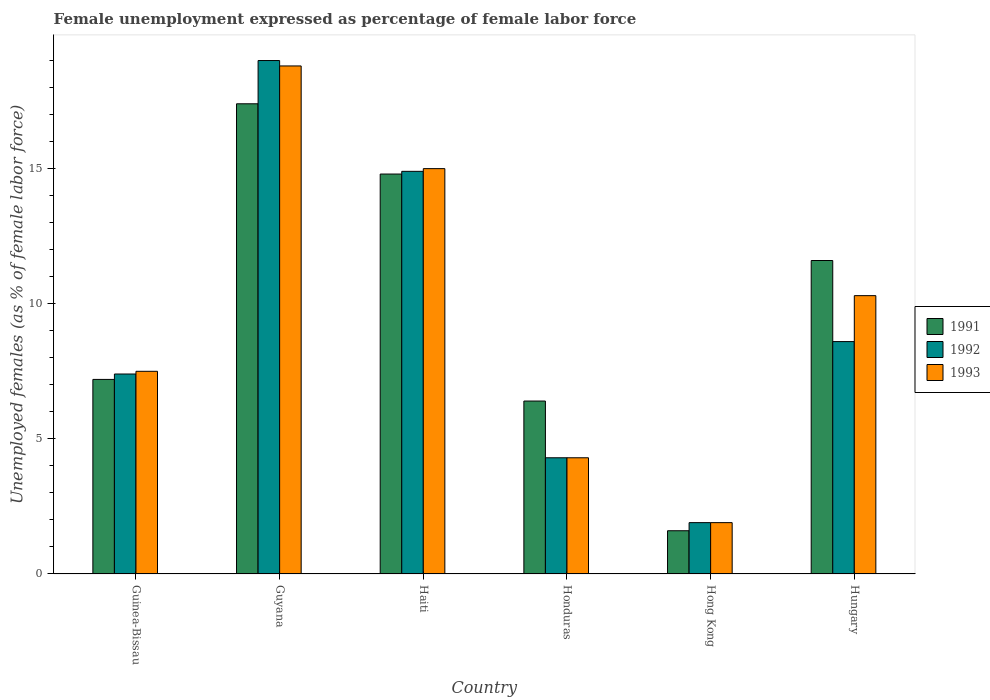How many bars are there on the 3rd tick from the right?
Your answer should be compact. 3. What is the label of the 4th group of bars from the left?
Give a very brief answer. Honduras. In how many cases, is the number of bars for a given country not equal to the number of legend labels?
Your answer should be compact. 0. What is the unemployment in females in in 1991 in Haiti?
Your answer should be compact. 14.8. Across all countries, what is the maximum unemployment in females in in 1993?
Ensure brevity in your answer.  18.8. Across all countries, what is the minimum unemployment in females in in 1993?
Ensure brevity in your answer.  1.9. In which country was the unemployment in females in in 1993 maximum?
Your response must be concise. Guyana. In which country was the unemployment in females in in 1993 minimum?
Provide a short and direct response. Hong Kong. What is the total unemployment in females in in 1992 in the graph?
Your answer should be very brief. 56.1. What is the difference between the unemployment in females in in 1993 in Honduras and that in Hong Kong?
Your answer should be compact. 2.4. What is the difference between the unemployment in females in in 1991 in Guyana and the unemployment in females in in 1993 in Hong Kong?
Your answer should be very brief. 15.5. What is the average unemployment in females in in 1993 per country?
Keep it short and to the point. 9.63. What is the difference between the unemployment in females in of/in 1993 and unemployment in females in of/in 1991 in Haiti?
Your answer should be compact. 0.2. What is the ratio of the unemployment in females in in 1993 in Haiti to that in Hong Kong?
Give a very brief answer. 7.89. Is the unemployment in females in in 1992 in Honduras less than that in Hong Kong?
Keep it short and to the point. No. What is the difference between the highest and the second highest unemployment in females in in 1992?
Give a very brief answer. -10.4. What is the difference between the highest and the lowest unemployment in females in in 1993?
Offer a very short reply. 16.9. What does the 2nd bar from the right in Haiti represents?
Give a very brief answer. 1992. Is it the case that in every country, the sum of the unemployment in females in in 1992 and unemployment in females in in 1993 is greater than the unemployment in females in in 1991?
Offer a terse response. Yes. Are all the bars in the graph horizontal?
Your answer should be very brief. No. Where does the legend appear in the graph?
Keep it short and to the point. Center right. How are the legend labels stacked?
Your answer should be very brief. Vertical. What is the title of the graph?
Make the answer very short. Female unemployment expressed as percentage of female labor force. What is the label or title of the Y-axis?
Keep it short and to the point. Unemployed females (as % of female labor force). What is the Unemployed females (as % of female labor force) in 1991 in Guinea-Bissau?
Your response must be concise. 7.2. What is the Unemployed females (as % of female labor force) of 1992 in Guinea-Bissau?
Give a very brief answer. 7.4. What is the Unemployed females (as % of female labor force) in 1993 in Guinea-Bissau?
Your response must be concise. 7.5. What is the Unemployed females (as % of female labor force) in 1991 in Guyana?
Offer a very short reply. 17.4. What is the Unemployed females (as % of female labor force) in 1993 in Guyana?
Provide a succinct answer. 18.8. What is the Unemployed females (as % of female labor force) of 1991 in Haiti?
Keep it short and to the point. 14.8. What is the Unemployed females (as % of female labor force) in 1992 in Haiti?
Provide a succinct answer. 14.9. What is the Unemployed females (as % of female labor force) of 1991 in Honduras?
Your answer should be compact. 6.4. What is the Unemployed females (as % of female labor force) of 1992 in Honduras?
Keep it short and to the point. 4.3. What is the Unemployed females (as % of female labor force) of 1993 in Honduras?
Give a very brief answer. 4.3. What is the Unemployed females (as % of female labor force) in 1991 in Hong Kong?
Provide a short and direct response. 1.6. What is the Unemployed females (as % of female labor force) in 1992 in Hong Kong?
Provide a succinct answer. 1.9. What is the Unemployed females (as % of female labor force) in 1993 in Hong Kong?
Offer a very short reply. 1.9. What is the Unemployed females (as % of female labor force) of 1991 in Hungary?
Your response must be concise. 11.6. What is the Unemployed females (as % of female labor force) in 1992 in Hungary?
Make the answer very short. 8.6. What is the Unemployed females (as % of female labor force) in 1993 in Hungary?
Your answer should be very brief. 10.3. Across all countries, what is the maximum Unemployed females (as % of female labor force) of 1991?
Ensure brevity in your answer.  17.4. Across all countries, what is the maximum Unemployed females (as % of female labor force) of 1992?
Ensure brevity in your answer.  19. Across all countries, what is the maximum Unemployed females (as % of female labor force) of 1993?
Your response must be concise. 18.8. Across all countries, what is the minimum Unemployed females (as % of female labor force) in 1991?
Your response must be concise. 1.6. Across all countries, what is the minimum Unemployed females (as % of female labor force) of 1992?
Ensure brevity in your answer.  1.9. Across all countries, what is the minimum Unemployed females (as % of female labor force) in 1993?
Your response must be concise. 1.9. What is the total Unemployed females (as % of female labor force) in 1992 in the graph?
Your answer should be compact. 56.1. What is the total Unemployed females (as % of female labor force) of 1993 in the graph?
Offer a terse response. 57.8. What is the difference between the Unemployed females (as % of female labor force) in 1992 in Guinea-Bissau and that in Guyana?
Provide a succinct answer. -11.6. What is the difference between the Unemployed females (as % of female labor force) in 1993 in Guinea-Bissau and that in Guyana?
Ensure brevity in your answer.  -11.3. What is the difference between the Unemployed females (as % of female labor force) of 1992 in Guinea-Bissau and that in Haiti?
Make the answer very short. -7.5. What is the difference between the Unemployed females (as % of female labor force) in 1993 in Guinea-Bissau and that in Haiti?
Keep it short and to the point. -7.5. What is the difference between the Unemployed females (as % of female labor force) of 1992 in Guinea-Bissau and that in Honduras?
Your answer should be compact. 3.1. What is the difference between the Unemployed females (as % of female labor force) in 1991 in Guinea-Bissau and that in Hong Kong?
Your answer should be compact. 5.6. What is the difference between the Unemployed females (as % of female labor force) of 1992 in Guinea-Bissau and that in Hong Kong?
Ensure brevity in your answer.  5.5. What is the difference between the Unemployed females (as % of female labor force) in 1993 in Guinea-Bissau and that in Hong Kong?
Keep it short and to the point. 5.6. What is the difference between the Unemployed females (as % of female labor force) of 1991 in Guinea-Bissau and that in Hungary?
Ensure brevity in your answer.  -4.4. What is the difference between the Unemployed females (as % of female labor force) of 1992 in Guinea-Bissau and that in Hungary?
Your answer should be compact. -1.2. What is the difference between the Unemployed females (as % of female labor force) in 1993 in Guinea-Bissau and that in Hungary?
Make the answer very short. -2.8. What is the difference between the Unemployed females (as % of female labor force) of 1992 in Guyana and that in Haiti?
Give a very brief answer. 4.1. What is the difference between the Unemployed females (as % of female labor force) of 1991 in Guyana and that in Honduras?
Your answer should be compact. 11. What is the difference between the Unemployed females (as % of female labor force) in 1992 in Guyana and that in Honduras?
Ensure brevity in your answer.  14.7. What is the difference between the Unemployed females (as % of female labor force) in 1993 in Guyana and that in Honduras?
Your answer should be compact. 14.5. What is the difference between the Unemployed females (as % of female labor force) in 1991 in Guyana and that in Hong Kong?
Your answer should be very brief. 15.8. What is the difference between the Unemployed females (as % of female labor force) in 1991 in Guyana and that in Hungary?
Your answer should be compact. 5.8. What is the difference between the Unemployed females (as % of female labor force) in 1991 in Haiti and that in Hong Kong?
Your answer should be compact. 13.2. What is the difference between the Unemployed females (as % of female labor force) in 1992 in Haiti and that in Hong Kong?
Your answer should be very brief. 13. What is the difference between the Unemployed females (as % of female labor force) in 1991 in Haiti and that in Hungary?
Ensure brevity in your answer.  3.2. What is the difference between the Unemployed females (as % of female labor force) of 1991 in Honduras and that in Hungary?
Make the answer very short. -5.2. What is the difference between the Unemployed females (as % of female labor force) in 1992 in Honduras and that in Hungary?
Your answer should be compact. -4.3. What is the difference between the Unemployed females (as % of female labor force) of 1993 in Honduras and that in Hungary?
Keep it short and to the point. -6. What is the difference between the Unemployed females (as % of female labor force) of 1991 in Hong Kong and that in Hungary?
Give a very brief answer. -10. What is the difference between the Unemployed females (as % of female labor force) of 1992 in Hong Kong and that in Hungary?
Your answer should be very brief. -6.7. What is the difference between the Unemployed females (as % of female labor force) in 1993 in Hong Kong and that in Hungary?
Your response must be concise. -8.4. What is the difference between the Unemployed females (as % of female labor force) in 1991 in Guinea-Bissau and the Unemployed females (as % of female labor force) in 1993 in Haiti?
Your answer should be very brief. -7.8. What is the difference between the Unemployed females (as % of female labor force) of 1992 in Guinea-Bissau and the Unemployed females (as % of female labor force) of 1993 in Haiti?
Your response must be concise. -7.6. What is the difference between the Unemployed females (as % of female labor force) of 1991 in Guinea-Bissau and the Unemployed females (as % of female labor force) of 1992 in Honduras?
Ensure brevity in your answer.  2.9. What is the difference between the Unemployed females (as % of female labor force) in 1991 in Guinea-Bissau and the Unemployed females (as % of female labor force) in 1993 in Honduras?
Offer a very short reply. 2.9. What is the difference between the Unemployed females (as % of female labor force) in 1992 in Guinea-Bissau and the Unemployed females (as % of female labor force) in 1993 in Honduras?
Offer a very short reply. 3.1. What is the difference between the Unemployed females (as % of female labor force) of 1991 in Guinea-Bissau and the Unemployed females (as % of female labor force) of 1992 in Hong Kong?
Ensure brevity in your answer.  5.3. What is the difference between the Unemployed females (as % of female labor force) of 1992 in Guinea-Bissau and the Unemployed females (as % of female labor force) of 1993 in Hungary?
Provide a succinct answer. -2.9. What is the difference between the Unemployed females (as % of female labor force) in 1991 in Guyana and the Unemployed females (as % of female labor force) in 1992 in Haiti?
Provide a succinct answer. 2.5. What is the difference between the Unemployed females (as % of female labor force) of 1991 in Guyana and the Unemployed females (as % of female labor force) of 1993 in Haiti?
Your response must be concise. 2.4. What is the difference between the Unemployed females (as % of female labor force) of 1992 in Guyana and the Unemployed females (as % of female labor force) of 1993 in Haiti?
Your answer should be compact. 4. What is the difference between the Unemployed females (as % of female labor force) in 1991 in Guyana and the Unemployed females (as % of female labor force) in 1992 in Honduras?
Provide a succinct answer. 13.1. What is the difference between the Unemployed females (as % of female labor force) in 1991 in Guyana and the Unemployed females (as % of female labor force) in 1992 in Hong Kong?
Ensure brevity in your answer.  15.5. What is the difference between the Unemployed females (as % of female labor force) in 1992 in Guyana and the Unemployed females (as % of female labor force) in 1993 in Hong Kong?
Keep it short and to the point. 17.1. What is the difference between the Unemployed females (as % of female labor force) in 1992 in Guyana and the Unemployed females (as % of female labor force) in 1993 in Hungary?
Your response must be concise. 8.7. What is the difference between the Unemployed females (as % of female labor force) of 1991 in Haiti and the Unemployed females (as % of female labor force) of 1992 in Honduras?
Your response must be concise. 10.5. What is the difference between the Unemployed females (as % of female labor force) in 1991 in Haiti and the Unemployed females (as % of female labor force) in 1993 in Honduras?
Offer a terse response. 10.5. What is the difference between the Unemployed females (as % of female labor force) of 1991 in Haiti and the Unemployed females (as % of female labor force) of 1993 in Hong Kong?
Give a very brief answer. 12.9. What is the difference between the Unemployed females (as % of female labor force) of 1992 in Haiti and the Unemployed females (as % of female labor force) of 1993 in Hong Kong?
Keep it short and to the point. 13. What is the difference between the Unemployed females (as % of female labor force) of 1991 in Haiti and the Unemployed females (as % of female labor force) of 1992 in Hungary?
Give a very brief answer. 6.2. What is the difference between the Unemployed females (as % of female labor force) of 1991 in Haiti and the Unemployed females (as % of female labor force) of 1993 in Hungary?
Provide a succinct answer. 4.5. What is the difference between the Unemployed females (as % of female labor force) in 1991 in Honduras and the Unemployed females (as % of female labor force) in 1992 in Hungary?
Keep it short and to the point. -2.2. What is the difference between the Unemployed females (as % of female labor force) in 1992 in Honduras and the Unemployed females (as % of female labor force) in 1993 in Hungary?
Make the answer very short. -6. What is the difference between the Unemployed females (as % of female labor force) of 1991 in Hong Kong and the Unemployed females (as % of female labor force) of 1993 in Hungary?
Offer a very short reply. -8.7. What is the average Unemployed females (as % of female labor force) of 1991 per country?
Offer a terse response. 9.83. What is the average Unemployed females (as % of female labor force) of 1992 per country?
Your response must be concise. 9.35. What is the average Unemployed females (as % of female labor force) in 1993 per country?
Your response must be concise. 9.63. What is the difference between the Unemployed females (as % of female labor force) of 1991 and Unemployed females (as % of female labor force) of 1993 in Guinea-Bissau?
Provide a succinct answer. -0.3. What is the difference between the Unemployed females (as % of female labor force) of 1991 and Unemployed females (as % of female labor force) of 1992 in Guyana?
Offer a very short reply. -1.6. What is the difference between the Unemployed females (as % of female labor force) in 1991 and Unemployed females (as % of female labor force) in 1993 in Guyana?
Keep it short and to the point. -1.4. What is the difference between the Unemployed females (as % of female labor force) of 1991 and Unemployed females (as % of female labor force) of 1992 in Haiti?
Your answer should be very brief. -0.1. What is the difference between the Unemployed females (as % of female labor force) of 1992 and Unemployed females (as % of female labor force) of 1993 in Haiti?
Offer a very short reply. -0.1. What is the difference between the Unemployed females (as % of female labor force) in 1991 and Unemployed females (as % of female labor force) in 1992 in Honduras?
Make the answer very short. 2.1. What is the difference between the Unemployed females (as % of female labor force) in 1991 and Unemployed females (as % of female labor force) in 1993 in Honduras?
Make the answer very short. 2.1. What is the difference between the Unemployed females (as % of female labor force) in 1992 and Unemployed females (as % of female labor force) in 1993 in Honduras?
Ensure brevity in your answer.  0. What is the difference between the Unemployed females (as % of female labor force) in 1991 and Unemployed females (as % of female labor force) in 1992 in Hungary?
Provide a short and direct response. 3. What is the difference between the Unemployed females (as % of female labor force) in 1991 and Unemployed females (as % of female labor force) in 1993 in Hungary?
Keep it short and to the point. 1.3. What is the difference between the Unemployed females (as % of female labor force) of 1992 and Unemployed females (as % of female labor force) of 1993 in Hungary?
Your answer should be very brief. -1.7. What is the ratio of the Unemployed females (as % of female labor force) of 1991 in Guinea-Bissau to that in Guyana?
Provide a succinct answer. 0.41. What is the ratio of the Unemployed females (as % of female labor force) in 1992 in Guinea-Bissau to that in Guyana?
Your answer should be compact. 0.39. What is the ratio of the Unemployed females (as % of female labor force) in 1993 in Guinea-Bissau to that in Guyana?
Provide a short and direct response. 0.4. What is the ratio of the Unemployed females (as % of female labor force) in 1991 in Guinea-Bissau to that in Haiti?
Make the answer very short. 0.49. What is the ratio of the Unemployed females (as % of female labor force) in 1992 in Guinea-Bissau to that in Haiti?
Offer a terse response. 0.5. What is the ratio of the Unemployed females (as % of female labor force) in 1992 in Guinea-Bissau to that in Honduras?
Your answer should be compact. 1.72. What is the ratio of the Unemployed females (as % of female labor force) of 1993 in Guinea-Bissau to that in Honduras?
Offer a terse response. 1.74. What is the ratio of the Unemployed females (as % of female labor force) in 1992 in Guinea-Bissau to that in Hong Kong?
Ensure brevity in your answer.  3.89. What is the ratio of the Unemployed females (as % of female labor force) of 1993 in Guinea-Bissau to that in Hong Kong?
Your response must be concise. 3.95. What is the ratio of the Unemployed females (as % of female labor force) in 1991 in Guinea-Bissau to that in Hungary?
Provide a short and direct response. 0.62. What is the ratio of the Unemployed females (as % of female labor force) in 1992 in Guinea-Bissau to that in Hungary?
Make the answer very short. 0.86. What is the ratio of the Unemployed females (as % of female labor force) in 1993 in Guinea-Bissau to that in Hungary?
Provide a short and direct response. 0.73. What is the ratio of the Unemployed females (as % of female labor force) of 1991 in Guyana to that in Haiti?
Your answer should be very brief. 1.18. What is the ratio of the Unemployed females (as % of female labor force) in 1992 in Guyana to that in Haiti?
Make the answer very short. 1.28. What is the ratio of the Unemployed females (as % of female labor force) in 1993 in Guyana to that in Haiti?
Offer a very short reply. 1.25. What is the ratio of the Unemployed females (as % of female labor force) of 1991 in Guyana to that in Honduras?
Offer a very short reply. 2.72. What is the ratio of the Unemployed females (as % of female labor force) of 1992 in Guyana to that in Honduras?
Your answer should be compact. 4.42. What is the ratio of the Unemployed females (as % of female labor force) of 1993 in Guyana to that in Honduras?
Make the answer very short. 4.37. What is the ratio of the Unemployed females (as % of female labor force) of 1991 in Guyana to that in Hong Kong?
Give a very brief answer. 10.88. What is the ratio of the Unemployed females (as % of female labor force) in 1993 in Guyana to that in Hong Kong?
Provide a succinct answer. 9.89. What is the ratio of the Unemployed females (as % of female labor force) of 1992 in Guyana to that in Hungary?
Ensure brevity in your answer.  2.21. What is the ratio of the Unemployed females (as % of female labor force) in 1993 in Guyana to that in Hungary?
Give a very brief answer. 1.83. What is the ratio of the Unemployed females (as % of female labor force) of 1991 in Haiti to that in Honduras?
Ensure brevity in your answer.  2.31. What is the ratio of the Unemployed females (as % of female labor force) in 1992 in Haiti to that in Honduras?
Your answer should be compact. 3.47. What is the ratio of the Unemployed females (as % of female labor force) of 1993 in Haiti to that in Honduras?
Ensure brevity in your answer.  3.49. What is the ratio of the Unemployed females (as % of female labor force) in 1991 in Haiti to that in Hong Kong?
Keep it short and to the point. 9.25. What is the ratio of the Unemployed females (as % of female labor force) of 1992 in Haiti to that in Hong Kong?
Make the answer very short. 7.84. What is the ratio of the Unemployed females (as % of female labor force) in 1993 in Haiti to that in Hong Kong?
Your answer should be compact. 7.89. What is the ratio of the Unemployed females (as % of female labor force) of 1991 in Haiti to that in Hungary?
Give a very brief answer. 1.28. What is the ratio of the Unemployed females (as % of female labor force) in 1992 in Haiti to that in Hungary?
Keep it short and to the point. 1.73. What is the ratio of the Unemployed females (as % of female labor force) in 1993 in Haiti to that in Hungary?
Offer a terse response. 1.46. What is the ratio of the Unemployed females (as % of female labor force) of 1991 in Honduras to that in Hong Kong?
Your answer should be very brief. 4. What is the ratio of the Unemployed females (as % of female labor force) of 1992 in Honduras to that in Hong Kong?
Offer a very short reply. 2.26. What is the ratio of the Unemployed females (as % of female labor force) in 1993 in Honduras to that in Hong Kong?
Make the answer very short. 2.26. What is the ratio of the Unemployed females (as % of female labor force) in 1991 in Honduras to that in Hungary?
Ensure brevity in your answer.  0.55. What is the ratio of the Unemployed females (as % of female labor force) in 1993 in Honduras to that in Hungary?
Offer a terse response. 0.42. What is the ratio of the Unemployed females (as % of female labor force) of 1991 in Hong Kong to that in Hungary?
Your answer should be very brief. 0.14. What is the ratio of the Unemployed females (as % of female labor force) of 1992 in Hong Kong to that in Hungary?
Your answer should be compact. 0.22. What is the ratio of the Unemployed females (as % of female labor force) of 1993 in Hong Kong to that in Hungary?
Provide a short and direct response. 0.18. What is the difference between the highest and the second highest Unemployed females (as % of female labor force) of 1991?
Your response must be concise. 2.6. What is the difference between the highest and the lowest Unemployed females (as % of female labor force) in 1992?
Keep it short and to the point. 17.1. 